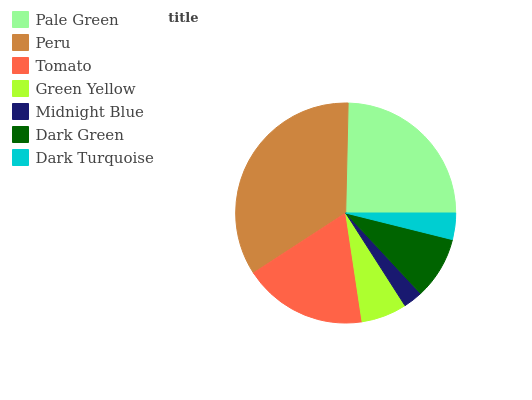Is Midnight Blue the minimum?
Answer yes or no. Yes. Is Peru the maximum?
Answer yes or no. Yes. Is Tomato the minimum?
Answer yes or no. No. Is Tomato the maximum?
Answer yes or no. No. Is Peru greater than Tomato?
Answer yes or no. Yes. Is Tomato less than Peru?
Answer yes or no. Yes. Is Tomato greater than Peru?
Answer yes or no. No. Is Peru less than Tomato?
Answer yes or no. No. Is Dark Green the high median?
Answer yes or no. Yes. Is Dark Green the low median?
Answer yes or no. Yes. Is Pale Green the high median?
Answer yes or no. No. Is Pale Green the low median?
Answer yes or no. No. 